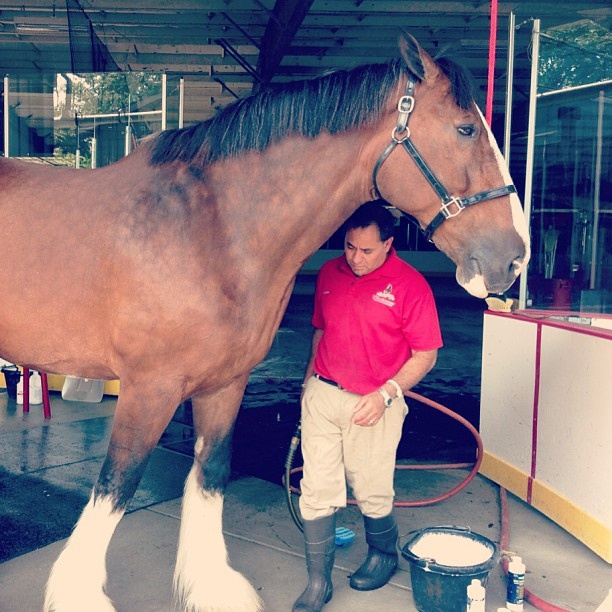Describe the objects in this image and their specific colors. I can see horse in gray, salmon, and darkgray tones, people in gray, brown, tan, and salmon tones, bottle in gray, ivory, navy, darkgray, and blue tones, and bottle in gray, ivory, darkgray, and blue tones in this image. 